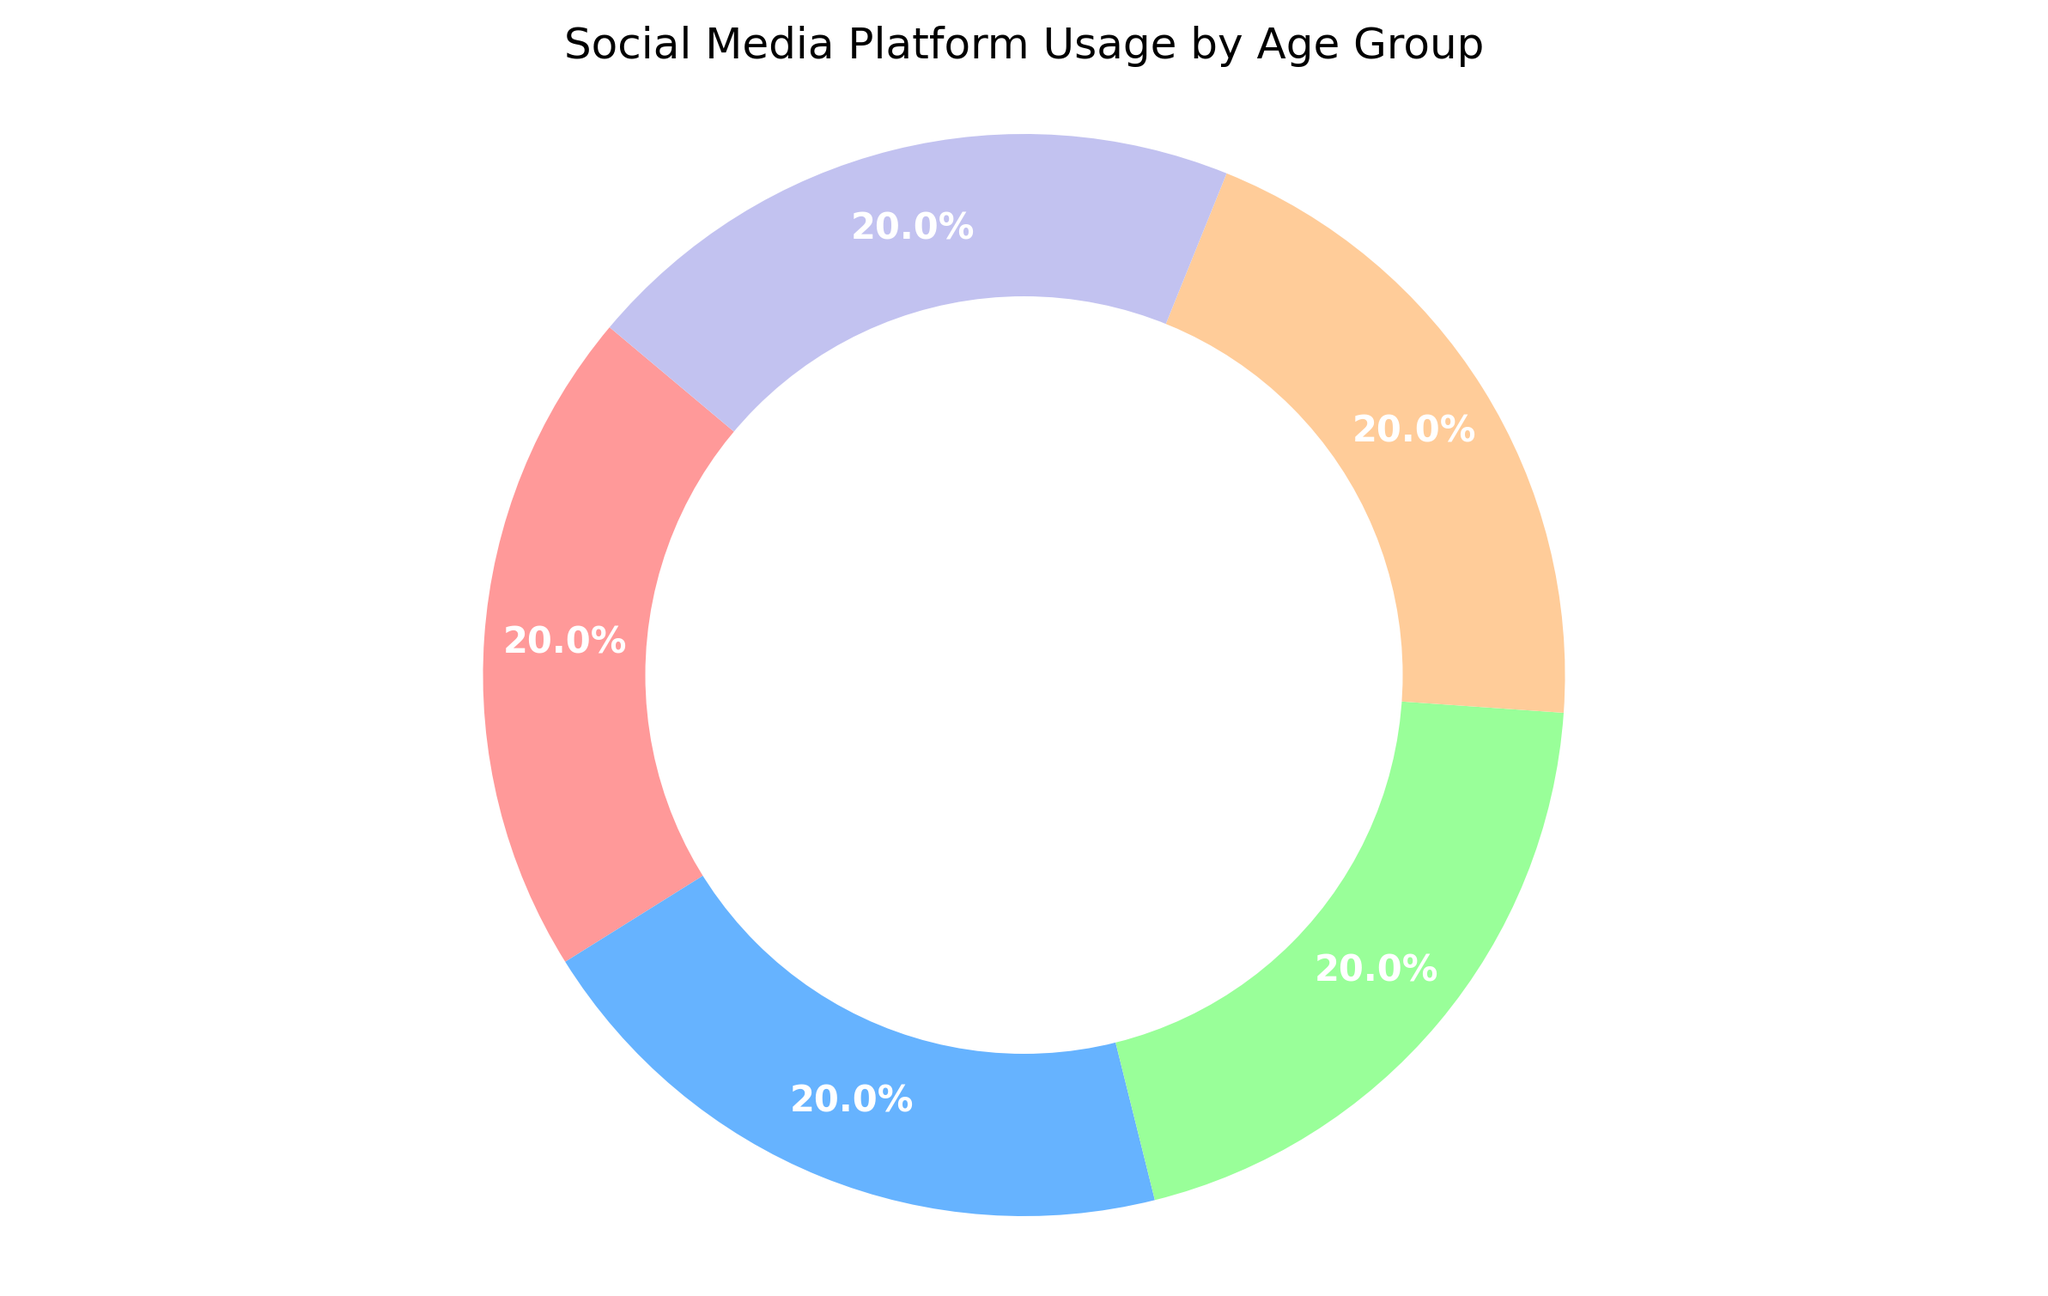Which social media platform has the highest overall usage percentage in the chart? To determine the platform with the highest usage, compare the percentages for each platform as depicted in the pie chart. The platform with the largest segment represents the highest overall usage.
Answer: TikTok How does the usage percentage of Facebook compare to that of Snapchat? Observe the size of the segments representing Facebook and Snapchat in the pie chart. Facebook has a larger segment, indicating a higher overall usage percentage compared to Snapchat.
Answer: Facebook's usage is higher Which platform is used the least by the 13-17 age group? Label and identify the smallest segment corresponding to the 13-17 age group for each platform. For this age group, Facebook has the smallest segment.
Answer: Facebook What is the combined usage percentage of Twitter and Instagram? Sum the percentages of the segments representing Twitter and Instagram. For example, if Twitter is 20% and Instagram is 20%, the total usage is 40%.
Answer: 40% Is the proportion of users aged 18-24 higher for TikTok or Facebook? Review the segments for users aged 18-24 for both TikTok and Facebook. TikTok has a larger segment, indicating higher usage among this age group.
Answer: TikTok Which social media platform shows the most balanced usage distribution across all age groups? Examine the segments to see which platform's usage percentage across age groups is more evenly distributed. Facebook, despite some variations, shows more balanced usage compared to the sharp declines in Snapchat and TikTok across age groups.
Answer: Facebook By what percentage does Snapchat's usage in the 13-17 age group exceed Facebook's usage in the same group? Subtract Facebook's 13-17 age group percentage from Snapchat's. For example, if Snapchat's is 30% and Facebook's is 5%, the difference is 30 - 5 = 25%.
Answer: 25% How does the usage of Instagram for the 25-34 age group compare to TikTok for the same group? Identify the segments for the 25-34 age group for both Instagram and TikTok. Instagram has a larger segment, meaning higher usage in this group.
Answer: Instagram's usage is higher Which age group contributes the least to the overall social media usage? Find the smallest segments among all age groups across all platforms. The 65+ age group has consistently low percentages, contributing the least overall.
Answer: 65+ What is the visual color representing Twitter on the pie chart? Identify the color used in the chart section labeled as Twitter. This segment's color representation is a distinctive visual feature.
Answer: Pale blue 